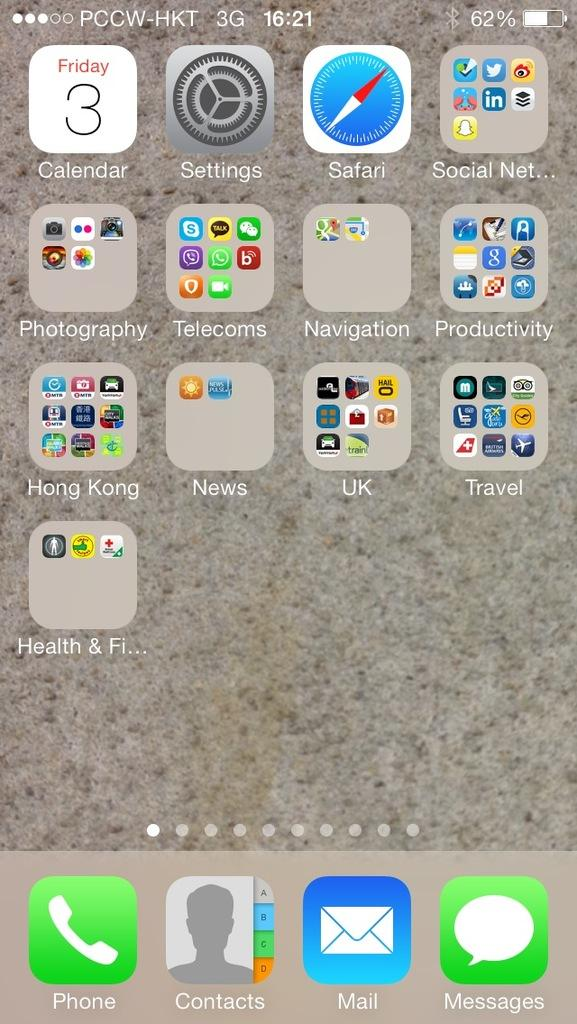<image>
Share a concise interpretation of the image provided. A phone's home screen displaying that it is Friday the 3rd 